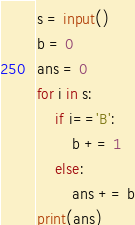<code> <loc_0><loc_0><loc_500><loc_500><_Python_>s = input()
b = 0
ans = 0
for i in s:
    if i=='B':
        b += 1
    else:
        ans += b
print(ans)</code> 